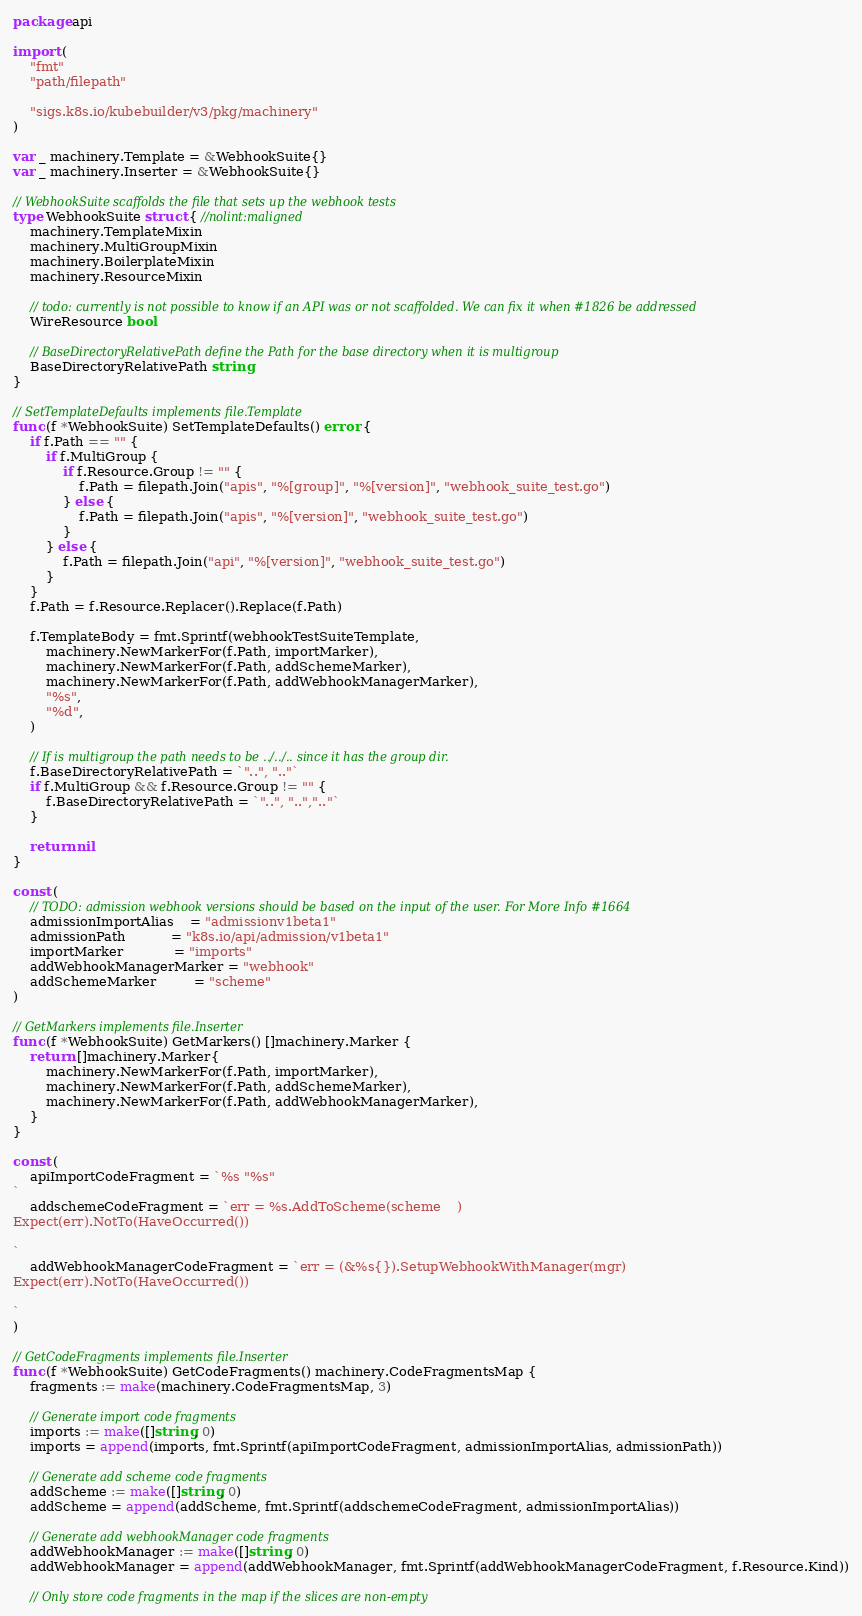Convert code to text. <code><loc_0><loc_0><loc_500><loc_500><_Go_>package api

import (
	"fmt"
	"path/filepath"

	"sigs.k8s.io/kubebuilder/v3/pkg/machinery"
)

var _ machinery.Template = &WebhookSuite{}
var _ machinery.Inserter = &WebhookSuite{}

// WebhookSuite scaffolds the file that sets up the webhook tests
type WebhookSuite struct { //nolint:maligned
	machinery.TemplateMixin
	machinery.MultiGroupMixin
	machinery.BoilerplateMixin
	machinery.ResourceMixin

	// todo: currently is not possible to know if an API was or not scaffolded. We can fix it when #1826 be addressed
	WireResource bool

	// BaseDirectoryRelativePath define the Path for the base directory when it is multigroup
	BaseDirectoryRelativePath string
}

// SetTemplateDefaults implements file.Template
func (f *WebhookSuite) SetTemplateDefaults() error {
	if f.Path == "" {
		if f.MultiGroup {
			if f.Resource.Group != "" {
				f.Path = filepath.Join("apis", "%[group]", "%[version]", "webhook_suite_test.go")
			} else {
				f.Path = filepath.Join("apis", "%[version]", "webhook_suite_test.go")
			}
		} else {
			f.Path = filepath.Join("api", "%[version]", "webhook_suite_test.go")
		}
	}
	f.Path = f.Resource.Replacer().Replace(f.Path)

	f.TemplateBody = fmt.Sprintf(webhookTestSuiteTemplate,
		machinery.NewMarkerFor(f.Path, importMarker),
		machinery.NewMarkerFor(f.Path, addSchemeMarker),
		machinery.NewMarkerFor(f.Path, addWebhookManagerMarker),
		"%s",
		"%d",
	)

	// If is multigroup the path needs to be ../../.. since it has the group dir.
	f.BaseDirectoryRelativePath = `"..", ".."`
	if f.MultiGroup && f.Resource.Group != "" {
		f.BaseDirectoryRelativePath = `"..", "..",".."`
	}

	return nil
}

const (
	// TODO: admission webhook versions should be based on the input of the user. For More Info #1664
	admissionImportAlias    = "admissionv1beta1"
	admissionPath           = "k8s.io/api/admission/v1beta1"
	importMarker            = "imports"
	addWebhookManagerMarker = "webhook"
	addSchemeMarker         = "scheme"
)

// GetMarkers implements file.Inserter
func (f *WebhookSuite) GetMarkers() []machinery.Marker {
	return []machinery.Marker{
		machinery.NewMarkerFor(f.Path, importMarker),
		machinery.NewMarkerFor(f.Path, addSchemeMarker),
		machinery.NewMarkerFor(f.Path, addWebhookManagerMarker),
	}
}

const (
	apiImportCodeFragment = `%s "%s"
`
	addschemeCodeFragment = `err = %s.AddToScheme(scheme	)
Expect(err).NotTo(HaveOccurred())

`
	addWebhookManagerCodeFragment = `err = (&%s{}).SetupWebhookWithManager(mgr)
Expect(err).NotTo(HaveOccurred())

`
)

// GetCodeFragments implements file.Inserter
func (f *WebhookSuite) GetCodeFragments() machinery.CodeFragmentsMap {
	fragments := make(machinery.CodeFragmentsMap, 3)

	// Generate import code fragments
	imports := make([]string, 0)
	imports = append(imports, fmt.Sprintf(apiImportCodeFragment, admissionImportAlias, admissionPath))

	// Generate add scheme code fragments
	addScheme := make([]string, 0)
	addScheme = append(addScheme, fmt.Sprintf(addschemeCodeFragment, admissionImportAlias))

	// Generate add webhookManager code fragments
	addWebhookManager := make([]string, 0)
	addWebhookManager = append(addWebhookManager, fmt.Sprintf(addWebhookManagerCodeFragment, f.Resource.Kind))

	// Only store code fragments in the map if the slices are non-empty</code> 